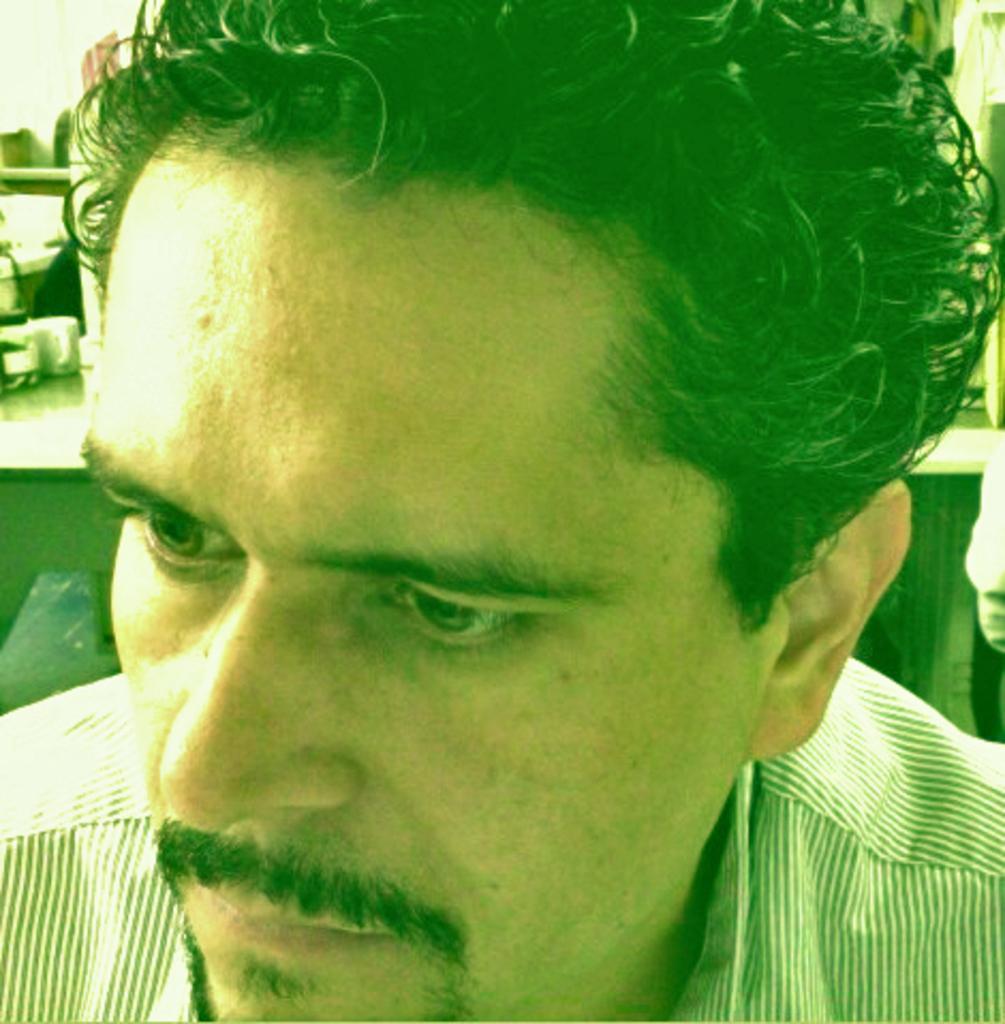Could you give a brief overview of what you see in this image? In this picture we can see a man and in the background we can see some objects. 